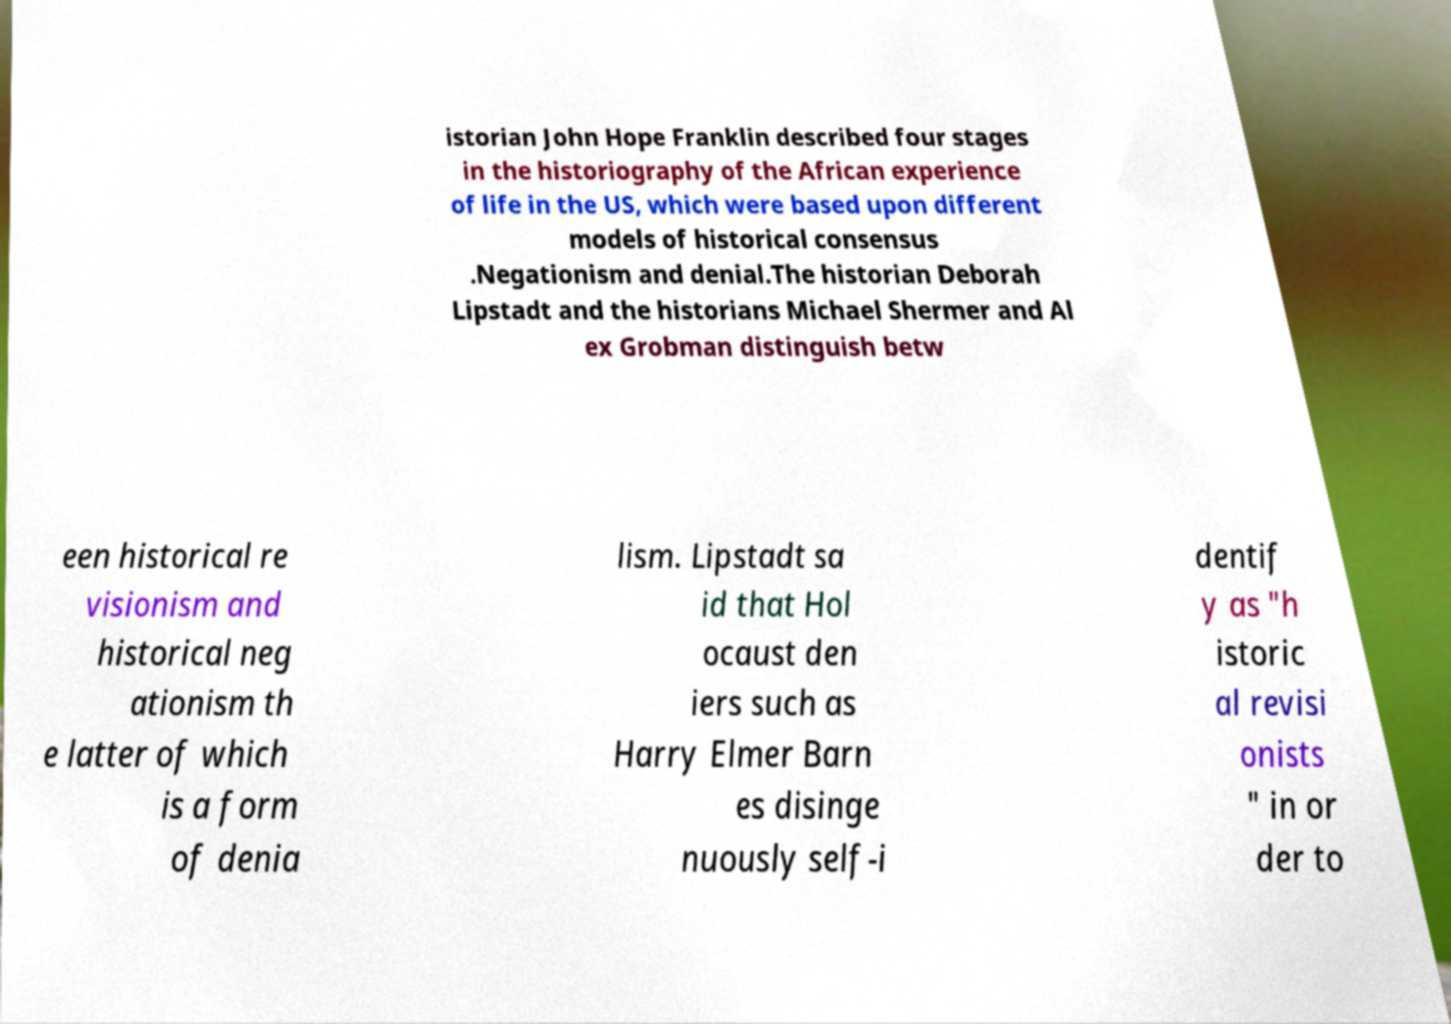Can you read and provide the text displayed in the image?This photo seems to have some interesting text. Can you extract and type it out for me? istorian John Hope Franklin described four stages in the historiography of the African experience of life in the US, which were based upon different models of historical consensus .Negationism and denial.The historian Deborah Lipstadt and the historians Michael Shermer and Al ex Grobman distinguish betw een historical re visionism and historical neg ationism th e latter of which is a form of denia lism. Lipstadt sa id that Hol ocaust den iers such as Harry Elmer Barn es disinge nuously self-i dentif y as "h istoric al revisi onists " in or der to 